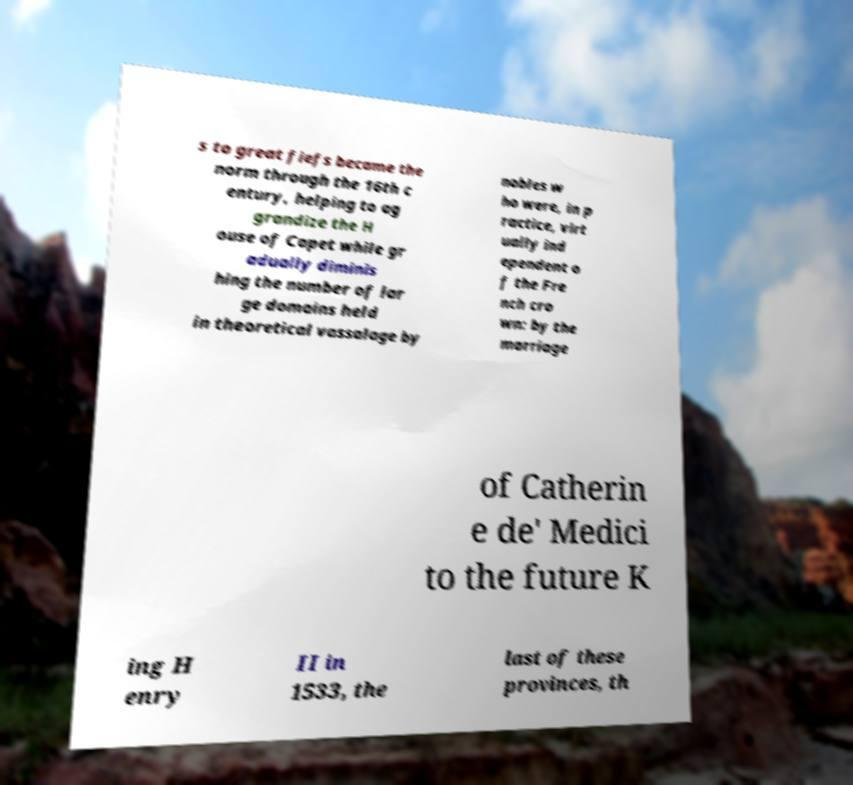I need the written content from this picture converted into text. Can you do that? s to great fiefs became the norm through the 16th c entury, helping to ag grandize the H ouse of Capet while gr adually diminis hing the number of lar ge domains held in theoretical vassalage by nobles w ho were, in p ractice, virt ually ind ependent o f the Fre nch cro wn: by the marriage of Catherin e de' Medici to the future K ing H enry II in 1533, the last of these provinces, th 